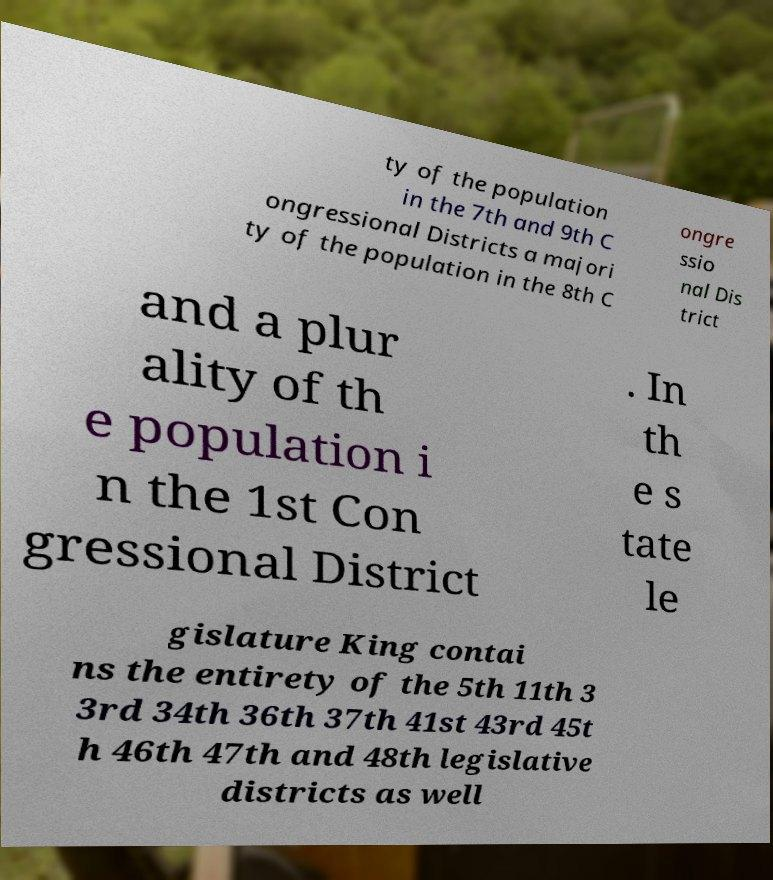Can you accurately transcribe the text from the provided image for me? ty of the population in the 7th and 9th C ongressional Districts a majori ty of the population in the 8th C ongre ssio nal Dis trict and a plur ality of th e population i n the 1st Con gressional District . In th e s tate le gislature King contai ns the entirety of the 5th 11th 3 3rd 34th 36th 37th 41st 43rd 45t h 46th 47th and 48th legislative districts as well 